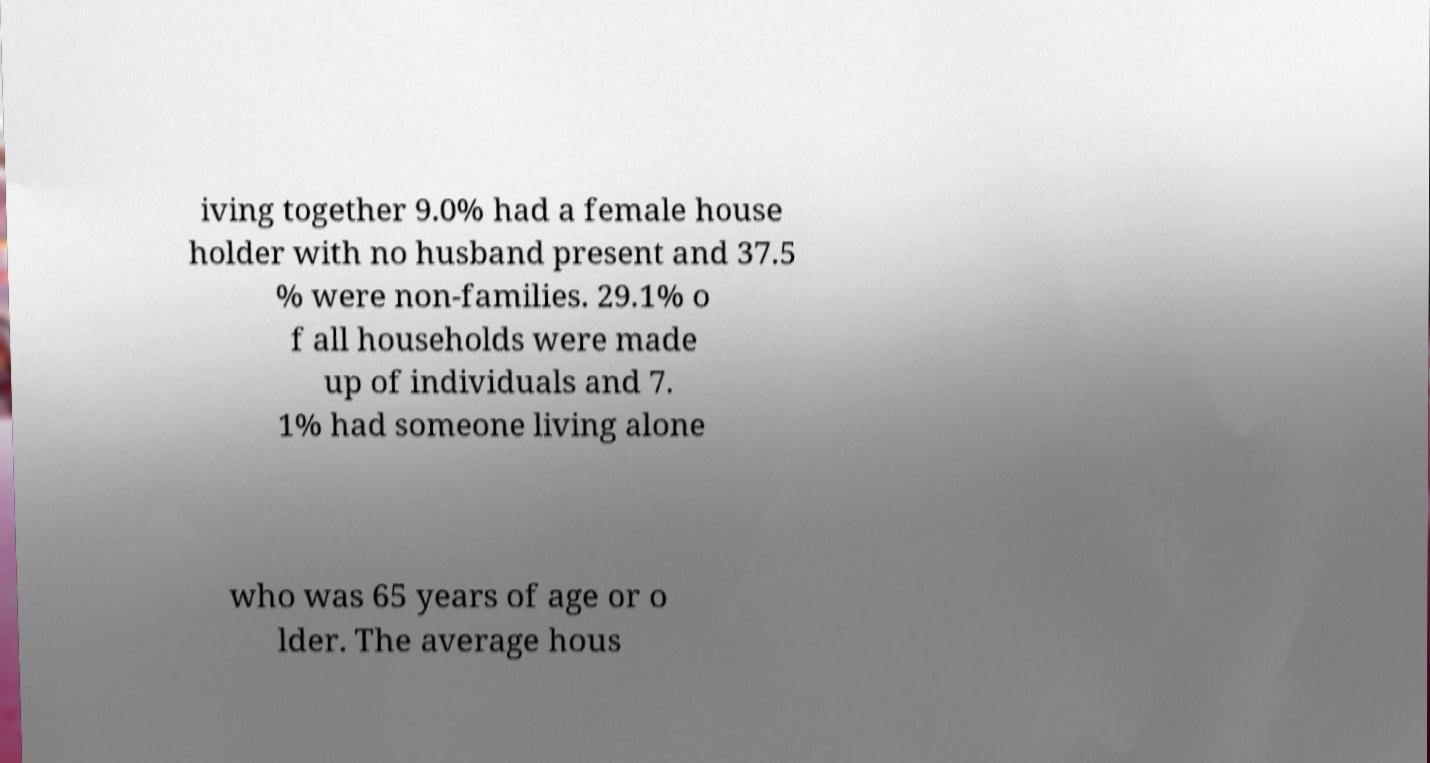What messages or text are displayed in this image? I need them in a readable, typed format. iving together 9.0% had a female house holder with no husband present and 37.5 % were non-families. 29.1% o f all households were made up of individuals and 7. 1% had someone living alone who was 65 years of age or o lder. The average hous 